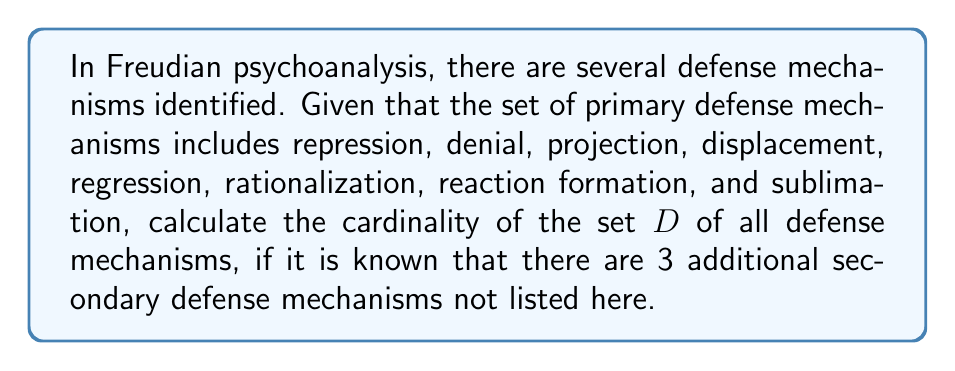Can you solve this math problem? To calculate the cardinality of the set $D$ of all defense mechanisms, we need to:

1. Count the number of primary defense mechanisms given in the question.
2. Add the number of additional secondary defense mechanisms mentioned.

Let's break it down step-by-step:

1. Primary defense mechanisms listed:
   - Repression
   - Denial
   - Projection
   - Displacement
   - Regression
   - Rationalization
   - Reaction formation
   - Sublimation

   Count of primary mechanisms: 8

2. Additional secondary defense mechanisms: 3

3. To find the cardinality of set $D$, we add these together:

   $|D| = \text{Primary mechanisms} + \text{Secondary mechanisms}$
   $|D| = 8 + 3 = 11$

Therefore, the cardinality of the set $D$ of all defense mechanisms is 11.
Answer: $|D| = 11$ 